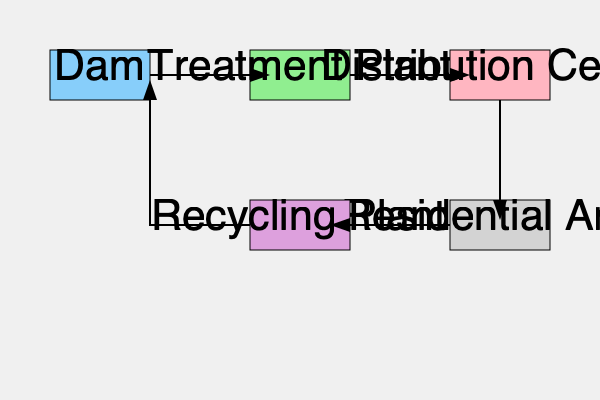In the water treatment and distribution process flowchart, which step comes immediately before the water reaches residential areas? To answer this question, we need to trace the flow of water through the system:

1. The process starts at the Dam, which is the water source.
2. Water flows from the Dam to the Treatment Plant.
3. After treatment, the water moves to the Distribution Center.
4. From the Distribution Center, water is sent directly to the Residential Area.
5. Used water from the Residential Area goes to the Recycling Plant.
6. Recycled water is then sent back to the Dam to restart the process.

By following this flow, we can see that the step immediately before the water reaches the Residential Area is the Distribution Center. The Distribution Center is responsible for allocating treated water to various parts of the city, including residential areas.
Answer: Distribution Center 